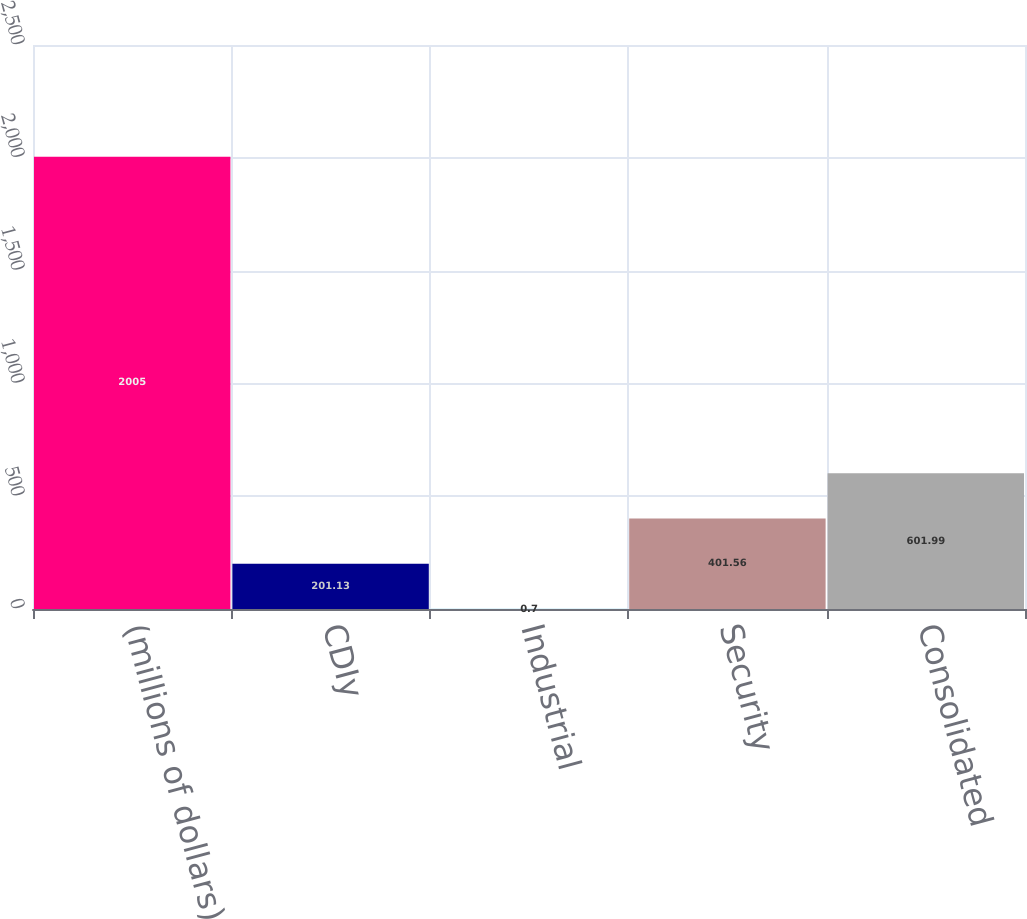Convert chart to OTSL. <chart><loc_0><loc_0><loc_500><loc_500><bar_chart><fcel>(millions of dollars)<fcel>CDIy<fcel>Industrial<fcel>Security<fcel>Consolidated<nl><fcel>2005<fcel>201.13<fcel>0.7<fcel>401.56<fcel>601.99<nl></chart> 